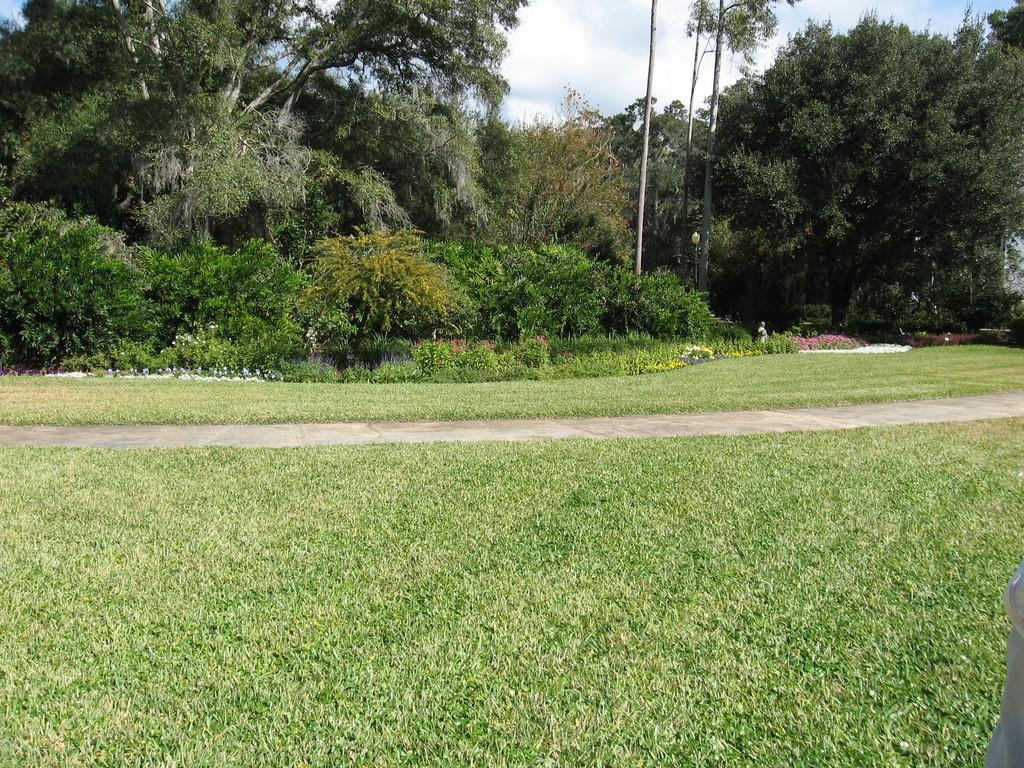Who or what is present in the image? There is a person in the image. What type of natural environment is depicted in the image? The image contains trees, plants, flowers, grass, and the sky. Can you describe the setting of the image? The image appears to be set in a natural environment with trees, plants, flowers, and grass. Is the person in the image trying to make a decision about crossing the quicksand? There is no quicksand present in the image, and therefore no decision-making about crossing it can be observed. 